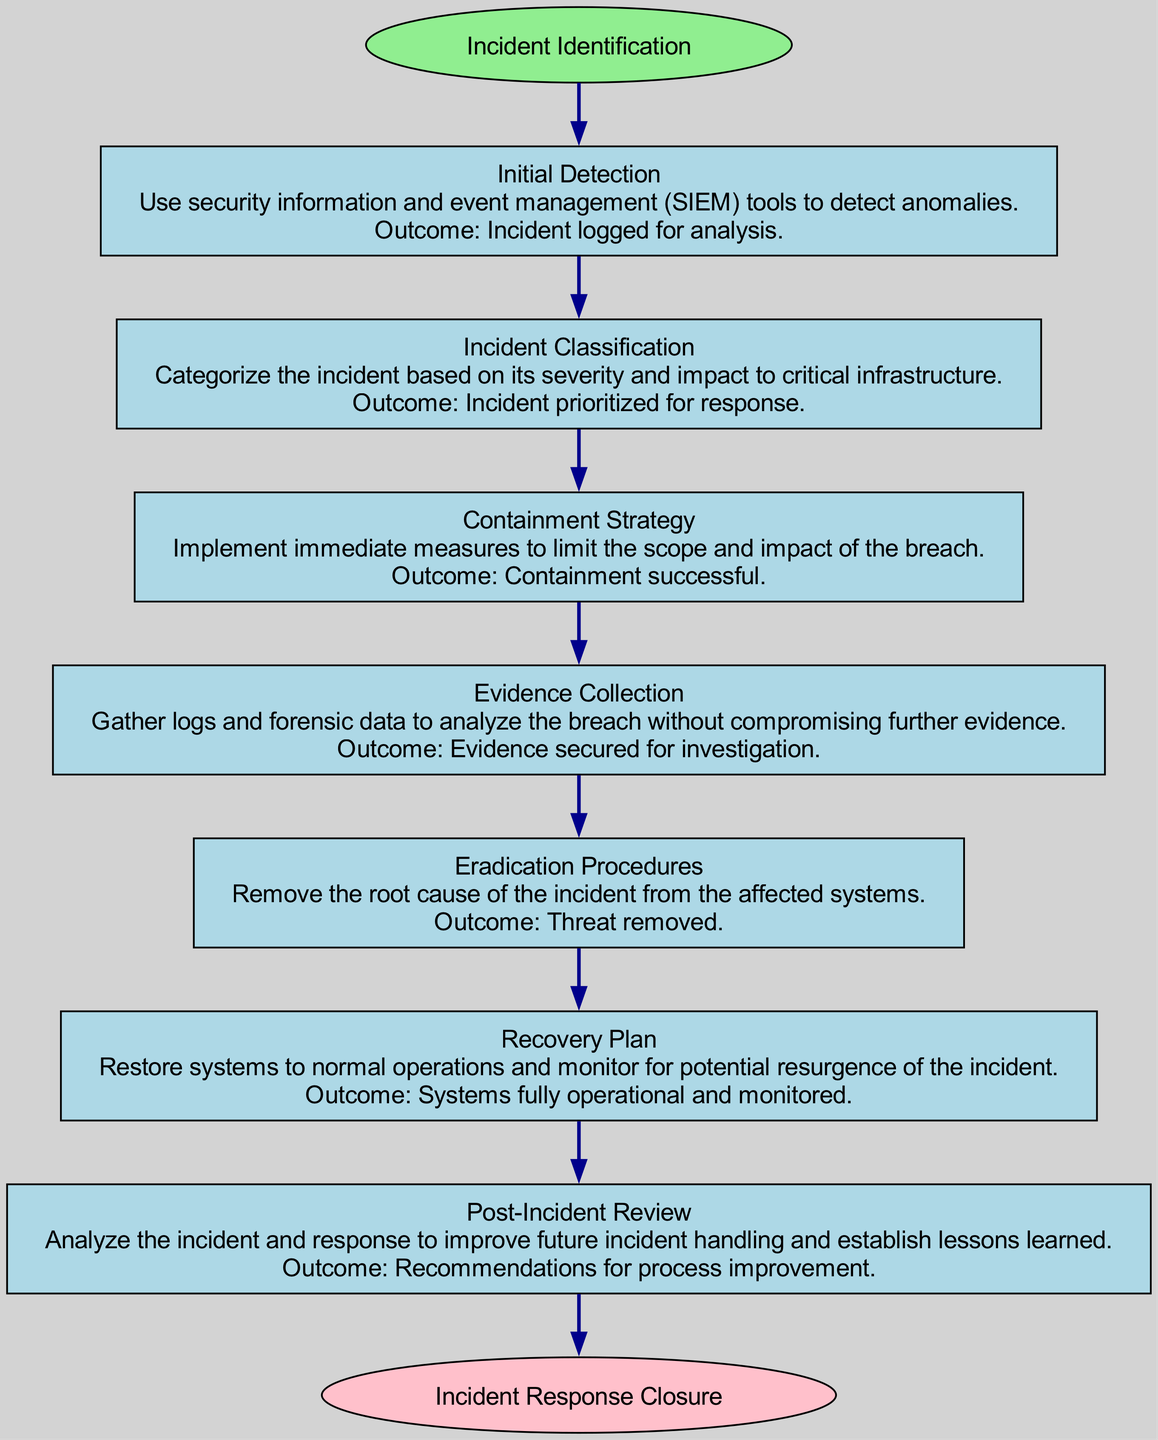What is the starting point of the workflow? The diagram indicates that the starting point of the workflow is labeled "Incident Identification." This is explicitly mentioned in the diagram where it shows the first node leading into the workflow.
Answer: Incident Identification How many steps are there in the workflow? By counting each of the nodes labeled as steps in the diagram, including "Initial Detection," "Incident Classification," "Containment Strategy," "Evidence Collection," "Eradication Procedures," "Recovery Plan," and "Post-Incident Review," there are a total of seven steps in the workflow.
Answer: 7 What is the outcome of the "Containment Strategy" step? The diagram specifies that the outcome of the "Containment Strategy" step is "Containment successful." This is directly shown in the corresponding node for that step within the workflow.
Answer: Containment successful What connects "Initial Detection" and "Incident Classification"? The arrow (edge) in the diagram visually connects "Initial Detection" to "Incident Classification." This shows the flow from one step to the next, indicating that after detecting the incident, the next step is to classify it.
Answer: An arrow What is the last step before the "Incident Response Closure"? The penultimate step before reaching the endpoint "Incident Response Closure" is labeled "Post-Incident Review." This can be deduced by following the path from the last step leading into the endpoint in the flowchart.
Answer: Post-Incident Review What is the purpose of the "Evidence Collection" step? The diagram describes the purpose of the "Evidence Collection" step as gathering logs and forensic data to analyze the breach. This is explicitly stated in the description section of that node in the workflow.
Answer: Gather logs and forensic data What action follows after "Evidence Collection"? According to the flow of the diagram, the action that follows "Evidence Collection" is "Eradication Procedures." This indicates a logical progression from collecting evidence to addressing the issue.
Answer: Eradication Procedures What shape is used for the start and end points in the diagram? The start point is represented with an ellipse shape, and the end point is also represented with an ellipse shape. This is a common practice in flowcharts to distinguish start and end points from other process steps.
Answer: Ellipse 